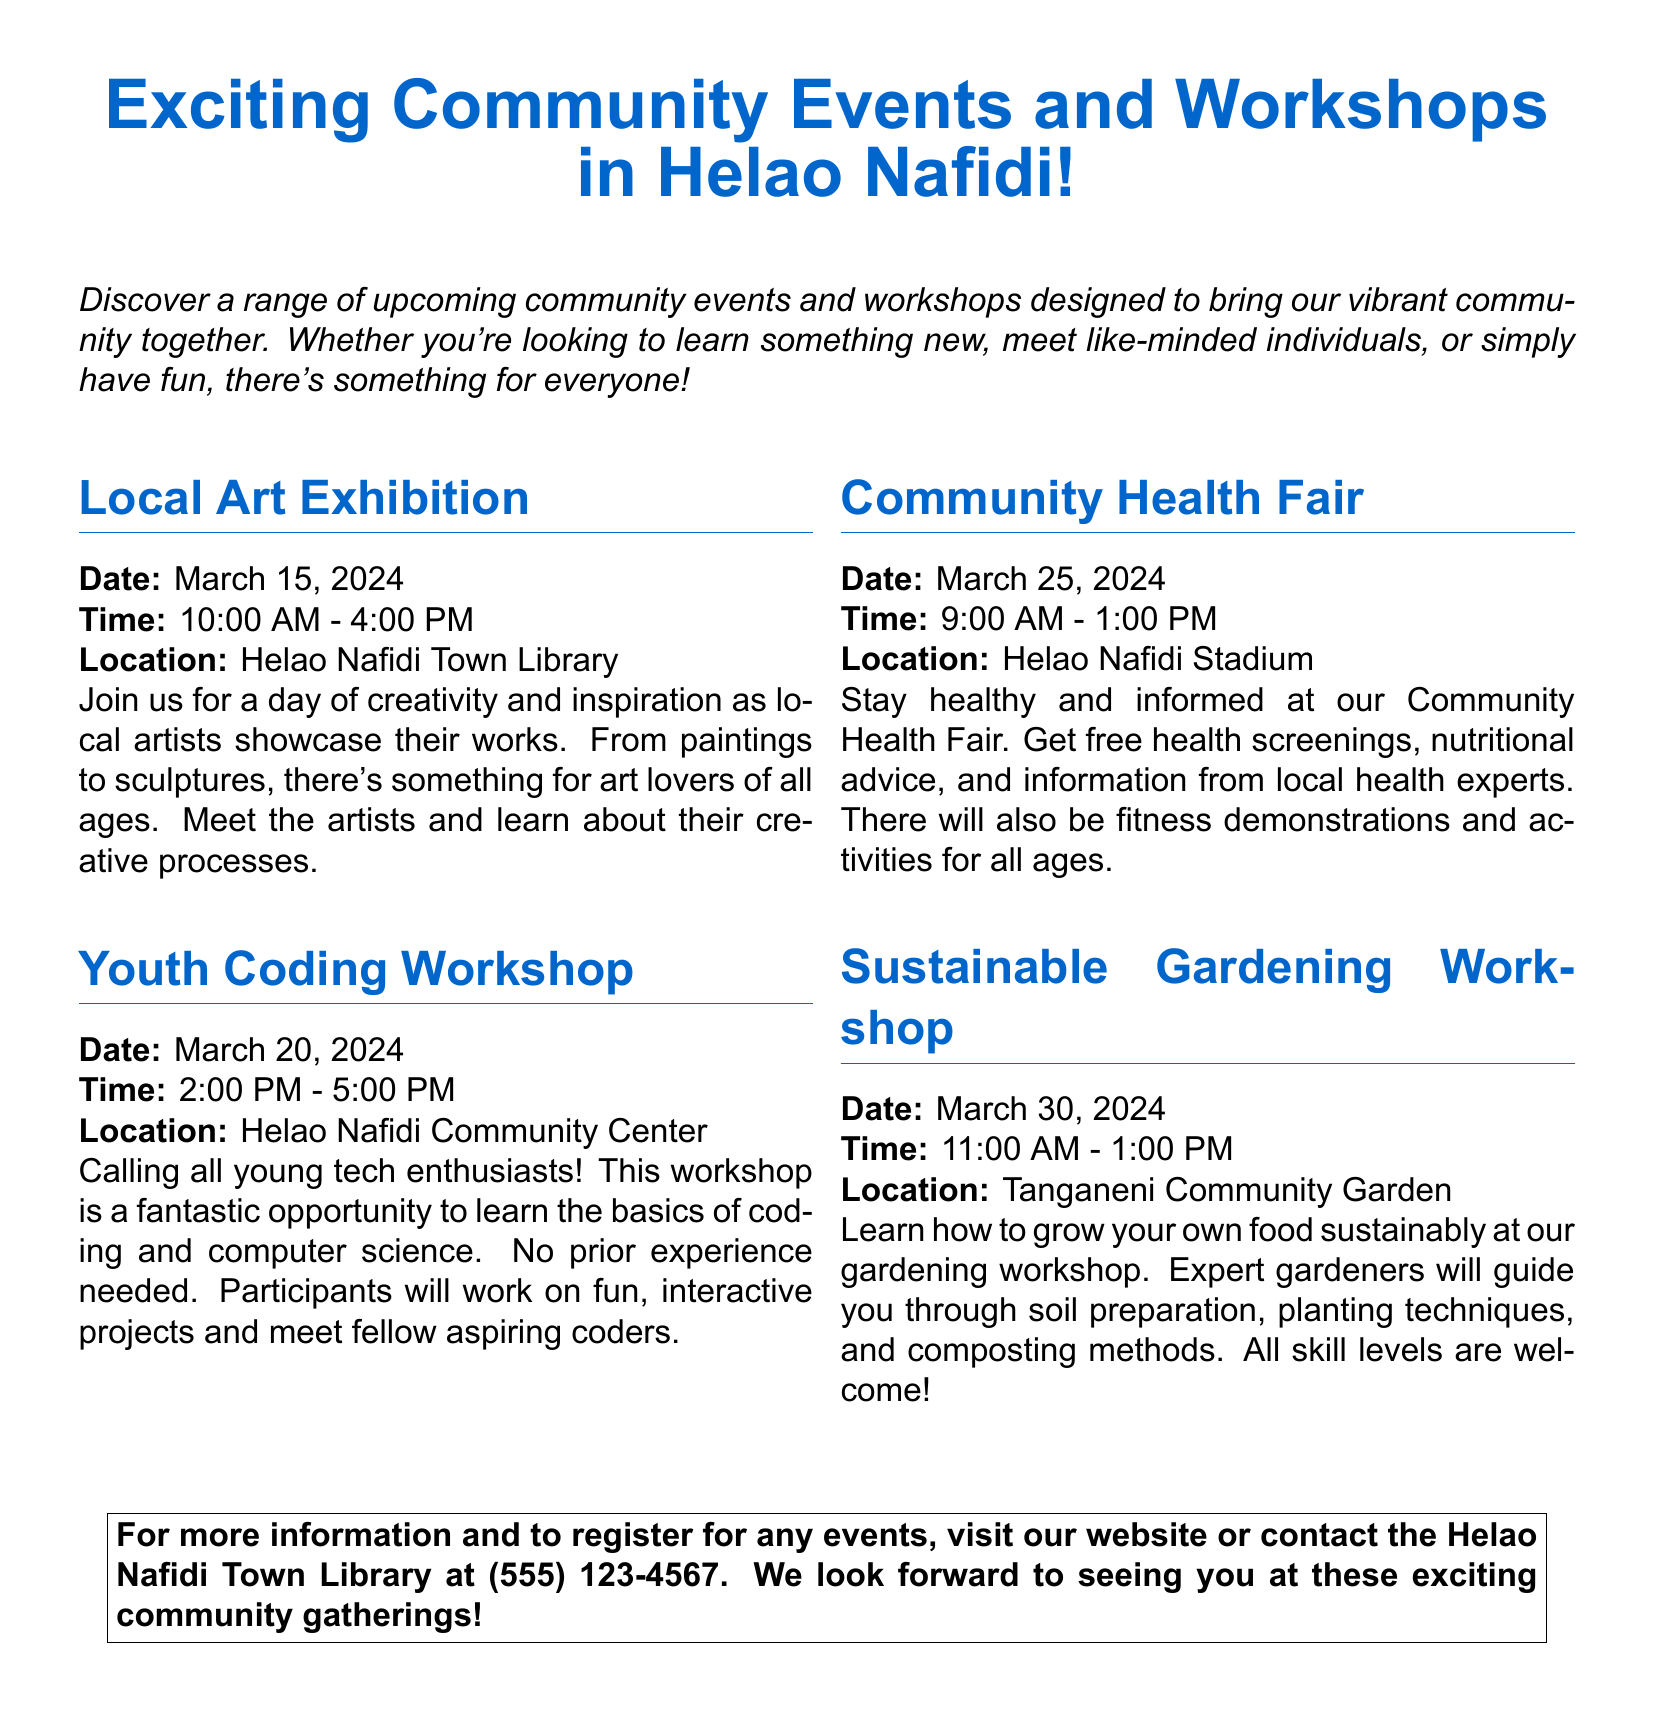What is the title of the flyer? The title can be found at the top of the document, highlighting the purpose of the content.
Answer: Exciting Community Events and Workshops in Helao Nafidi! When is the Local Art Exhibition scheduled? The date for the Local Art Exhibition is listed under its respective section in the document.
Answer: March 15, 2024 Where will the Youth Coding Workshop take place? The location for the Youth Coding Workshop is specified in its section within the document.
Answer: Helao Nafidi Community Center What time does the Community Health Fair start? The start time for the Community Health Fair is mentioned clearly in that section of the flyer.
Answer: 9:00 AM What is the main focus of the Sustainable Gardening Workshop? The main topic of the Sustainable Gardening Workshop is explained in the text under its section.
Answer: Grow your own food sustainably How long is the Youth Coding Workshop? The duration of the Youth Coding Workshop can be calculated based on its start and end times noted in the document.
Answer: 3 hours How many community events are detailed in the flyer? The number of events can be counted by assessing each section of the document.
Answer: 4 What type of activities will be offered at the Community Health Fair? The types of activities available at the Community Health Fair are outlined in that section of the flyer.
Answer: Health screenings, nutritional advice, fitness demonstrations What do participants need to do to register for the events? The instructions for registration are provided at the bottom of the flyer in the contact information section.
Answer: Visit the website or contact the library 